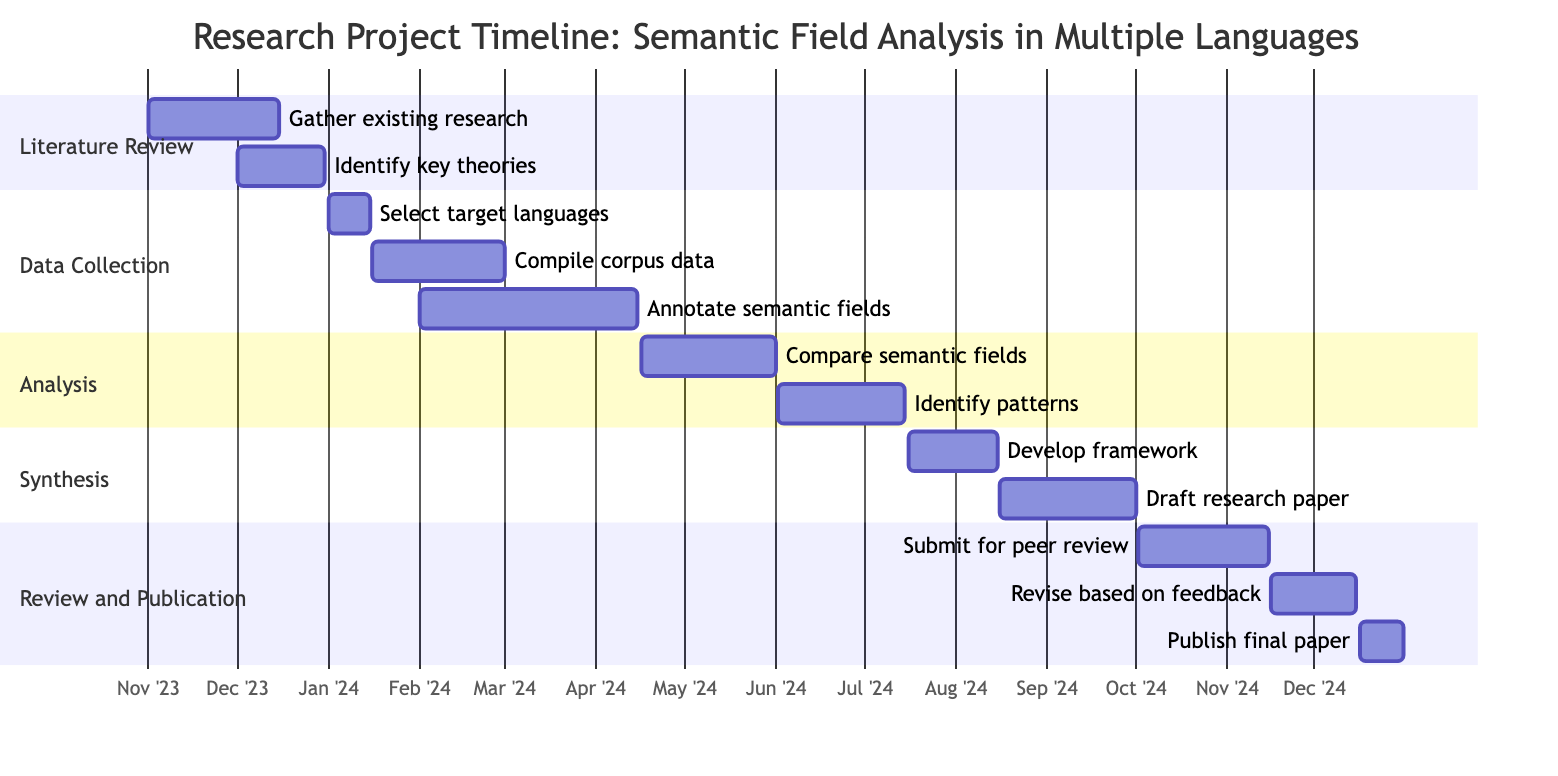What is the duration of the "Gather existing research" task? The "Gather existing research" task starts on November 1, 2023, and ends on December 15, 2023. To find the duration, subtract the start date from the end date, which gives us 45 days.
Answer: 45 days When does the "Identify cross-linguistic patterns" task start? According to the timeline, the "Identify cross-linguistic patterns" task begins on June 2, 2024.
Answer: June 2, 2024 How many tasks are there in the "Data Collection" phase? In the "Data Collection" phase, there are three tasks: "Select target languages," "Compile corpus data from each language," and "Annotate semantic fields within corpora." Counting these gives us a total of three tasks.
Answer: 3 What is the last task of the project? The last task shown in the Gantt chart is "Publish final paper," which is scheduled to end on December 31, 2024.
Answer: Publish final paper Which phase has overlapping tasks? The "Data Collection" phase has overlapping tasks. Specifically, "Compile corpus data from each language" overlaps with "Annotate semantic fields within corpora," as the former runs from January 16 to March 1 and the latter from February 1 to April 15.
Answer: Data Collection What is the earliest start date of any task in the project? The earliest start date of any task in the project is November 1, 2023, which is the start date for the "Gather existing research" task in the "Literature Review" phase.
Answer: November 1, 2023 Which task takes the longest to complete? The task "Annotate semantic fields within corpora" takes the longest to complete, spanning from February 1, 2024, to April 15, 2024, for a total of 74 days.
Answer: Annotate semantic fields within corpora What is the total time allocated for the "Synthesis" phase? The "Synthesis" phase contains two tasks: "Develop comprehensive framework for semantic analysis" (31 days) and "Draft research paper" (46 days). Adding these together gives a total of 77 days for the phase.
Answer: 77 days What is the start date of the "Review and Publication" phase? The "Review and Publication" phase starts on October 2, 2024, when the task "Submit paper for peer review" begins.
Answer: October 2, 2024 